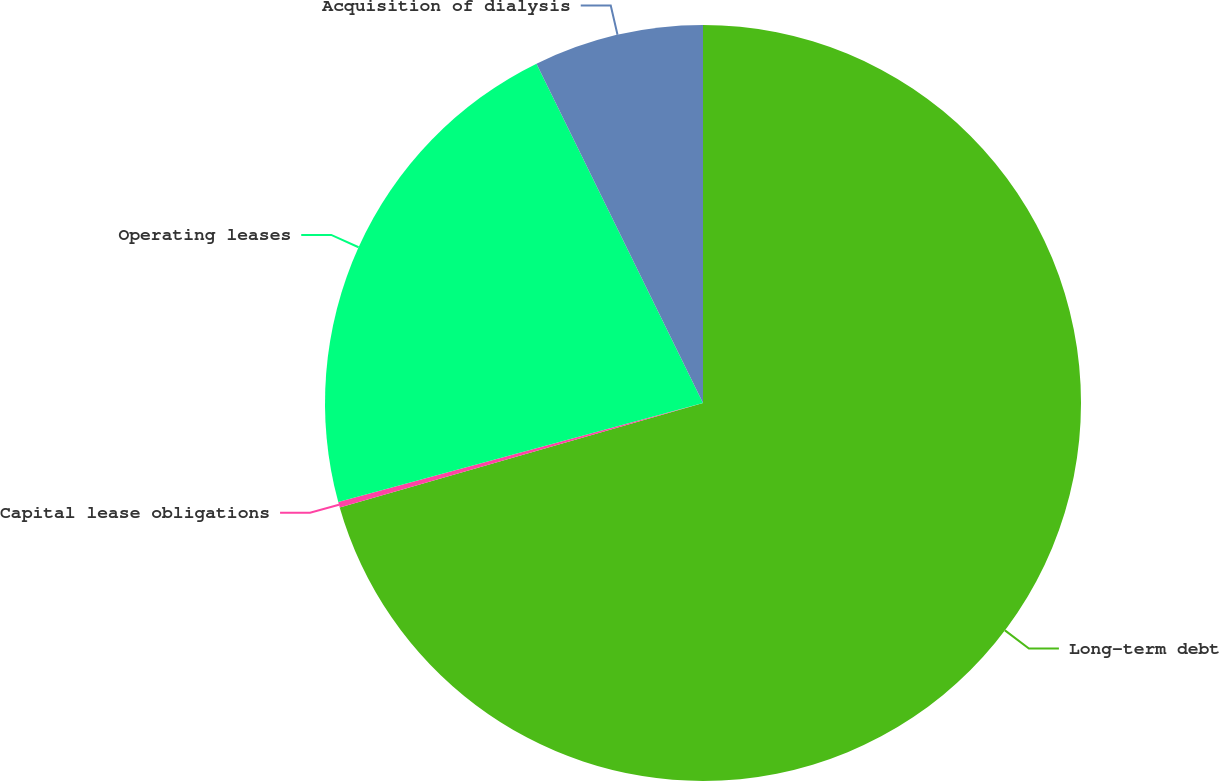<chart> <loc_0><loc_0><loc_500><loc_500><pie_chart><fcel>Long-term debt<fcel>Capital lease obligations<fcel>Operating leases<fcel>Acquisition of dialysis<nl><fcel>70.54%<fcel>0.23%<fcel>21.96%<fcel>7.26%<nl></chart> 